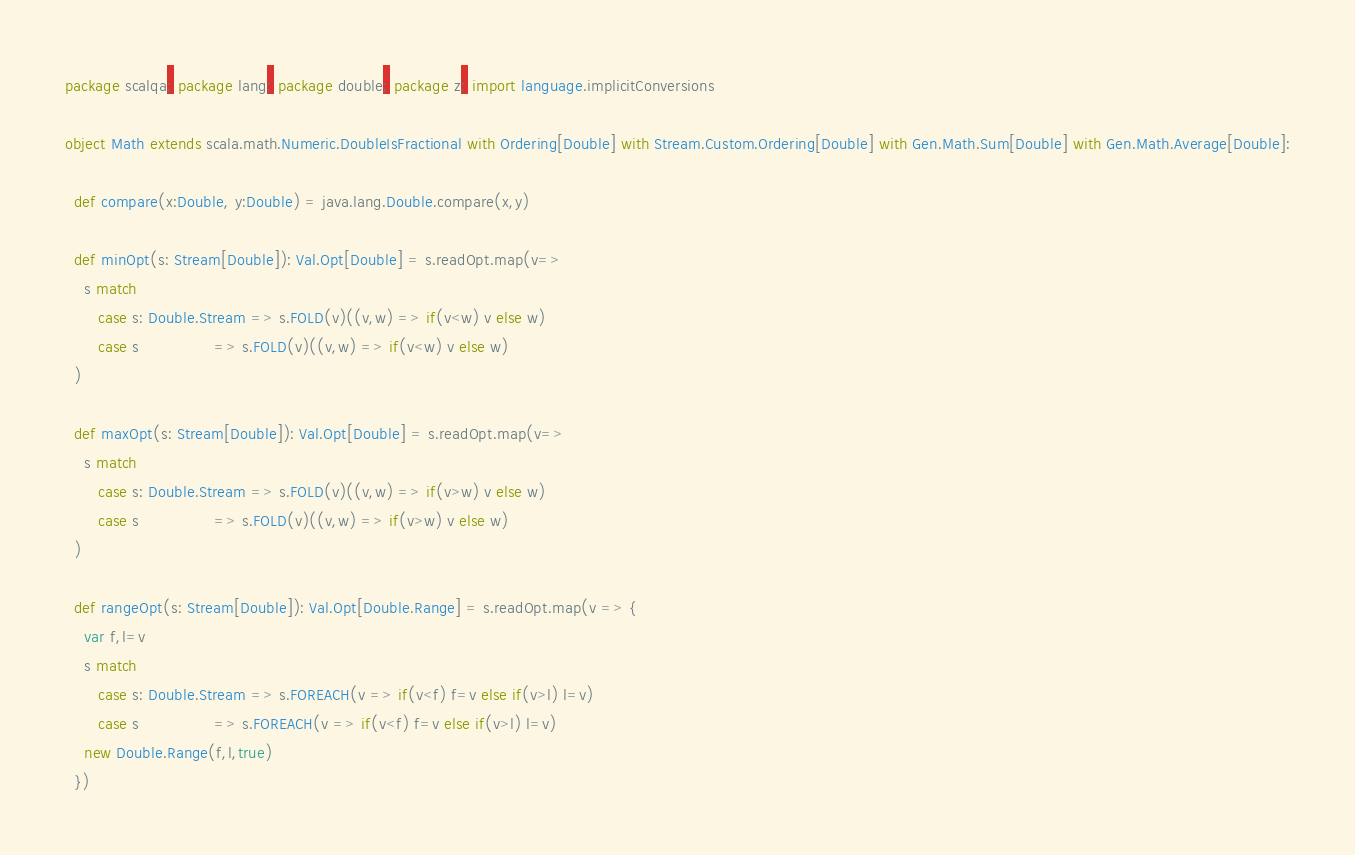<code> <loc_0><loc_0><loc_500><loc_500><_Scala_>package scalqa; package lang; package double; package z; import language.implicitConversions

object Math extends scala.math.Numeric.DoubleIsFractional with Ordering[Double] with Stream.Custom.Ordering[Double] with Gen.Math.Sum[Double] with Gen.Math.Average[Double]:

  def compare(x:Double, y:Double) = java.lang.Double.compare(x,y)

  def minOpt(s: Stream[Double]): Val.Opt[Double] = s.readOpt.map(v=>
    s match
       case s: Double.Stream => s.FOLD(v)((v,w) => if(v<w) v else w)
       case s                => s.FOLD(v)((v,w) => if(v<w) v else w)
  )

  def maxOpt(s: Stream[Double]): Val.Opt[Double] = s.readOpt.map(v=>
    s match
       case s: Double.Stream => s.FOLD(v)((v,w) => if(v>w) v else w)
       case s                => s.FOLD(v)((v,w) => if(v>w) v else w)
  )

  def rangeOpt(s: Stream[Double]): Val.Opt[Double.Range] = s.readOpt.map(v => {
    var f,l=v
    s match
       case s: Double.Stream => s.FOREACH(v => if(v<f) f=v else if(v>l) l=v)
       case s                => s.FOREACH(v => if(v<f) f=v else if(v>l) l=v)
    new Double.Range(f,l,true)
  })
</code> 